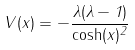Convert formula to latex. <formula><loc_0><loc_0><loc_500><loc_500>V ( x ) = - \frac { \lambda ( \lambda - 1 ) } { \cosh ( x ) ^ { 2 } }</formula> 